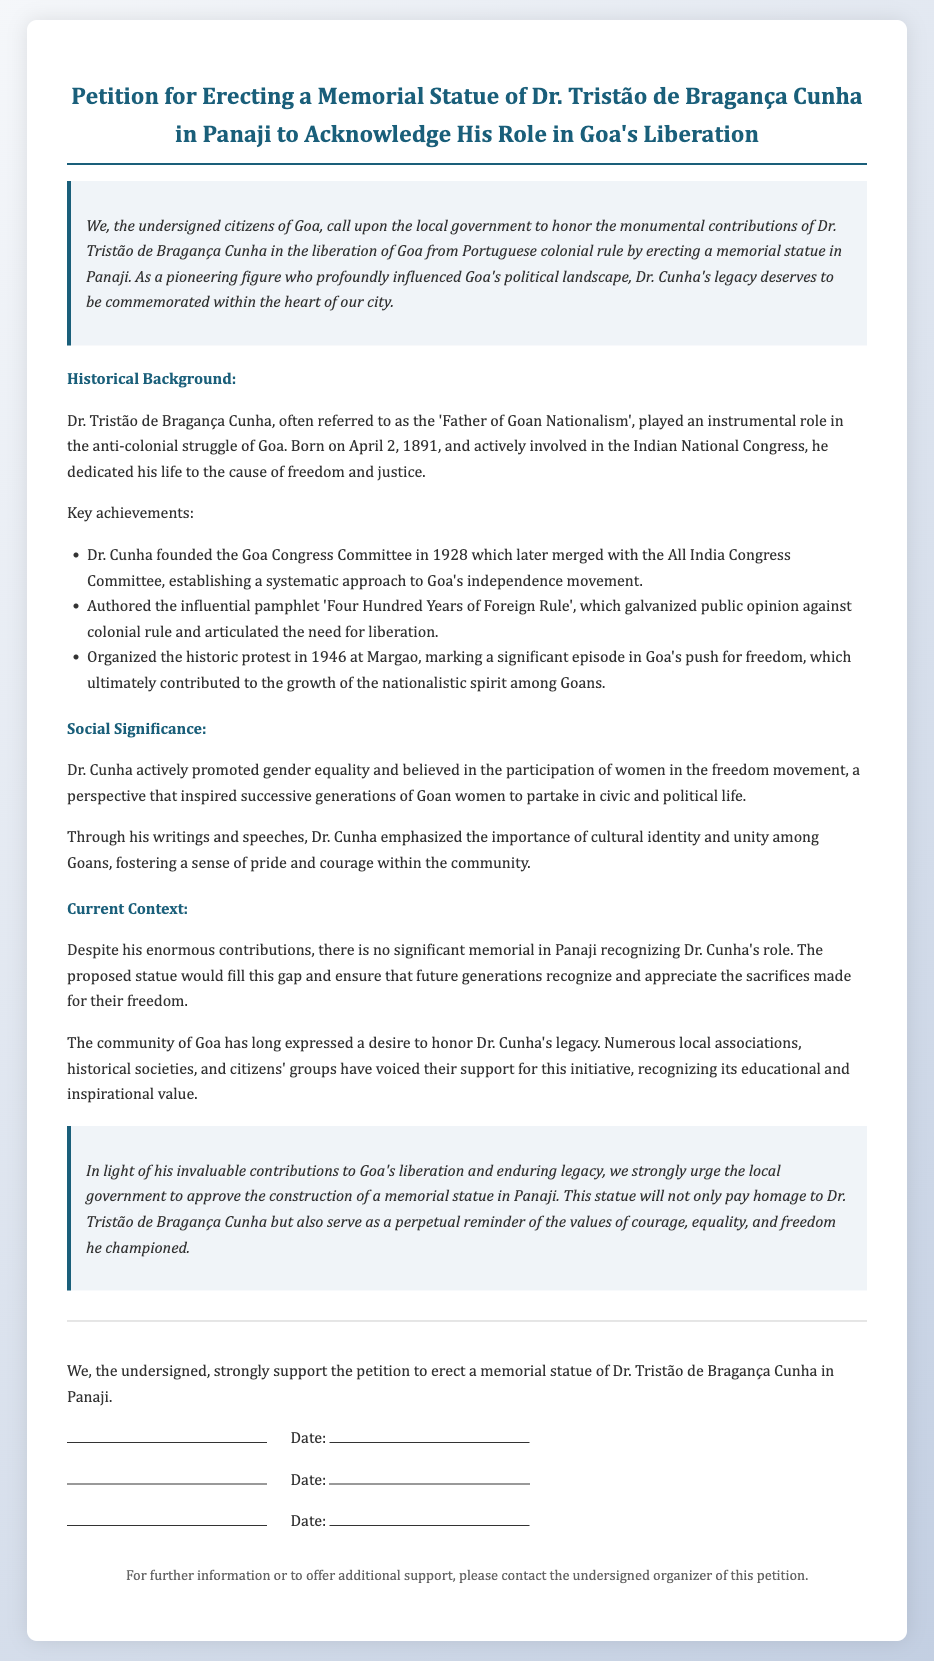What is the title of the petition? The title of the petition is found at the top of the document, prominently displayed.
Answer: Petition for Erecting a Memorial Statue of Dr. Tristão de Bragança Cunha in Panaji to Acknowledge His Role in Goa's Liberation Who is referred to as the 'Father of Goan Nationalism'? This title is used to describe Dr. Tristão de Bragança Cunha within the historical background of the document.
Answer: Dr. Tristão de Bragança Cunha What year was Dr. Tristão de Bragança Cunha born? The document states his birth year in the historical background section.
Answer: 1891 What significant event did Dr. Cunha organize in 1946? The document mentions this event in the context of Goa's push for freedom.
Answer: The historic protest in Margao What did Dr. Cunha advocate for in the freedom movement? The document highlights his belief in a certain value that influenced women's participation.
Answer: Gender equality How many times does the word "petition" appear in the document? Counting the occurrences of a specific term provides insight into the document's focus.
Answer: 3 What is the purpose of erecting a statue according to the petition? The document outlines the main intent behind the proposed monument.
Answer: To honor Dr. Tristão de Bragança Cunha What kind of local organizations support the petition? The document describes various groups that have expressed their backing for the initiative.
Answer: Local associations and historical societies What is the date of signature for the last line in the signature section? The format of the signature section allows for specifying signatures' dates, though none are provided.
Answer: No specific date given 